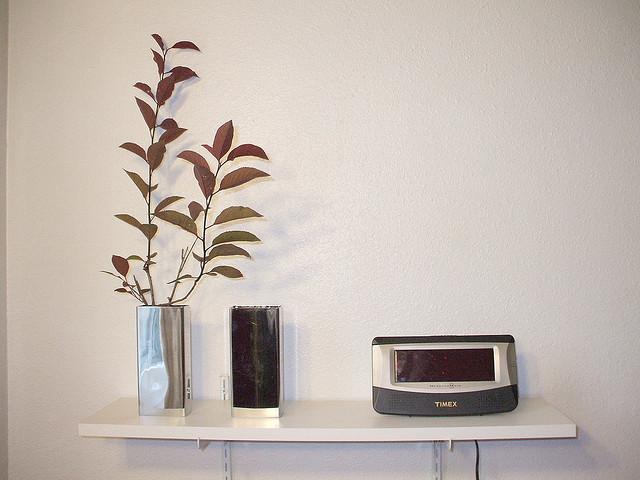Are the vases the same color?
Short answer required. No. What is next to the bear on the left?
Give a very brief answer. No bear. How much water does the plant need in the photo?
Keep it brief. Little. Is this wall red?
Write a very short answer. No. Is the plant alive/healthy?
Quick response, please. Yes. Is there a clock?
Write a very short answer. Yes. How many different flowers are there?
Concise answer only. 1. What room is this?
Concise answer only. Living room. What is in the vase?
Short answer required. Plant. What kind of appliance is this?
Answer briefly. Clock. What color is the shelf?
Concise answer only. White. What color are the flowers?
Keep it brief. Brown. How many vases are up against the wall?
Concise answer only. 2. How many hearts are there?
Be succinct. 0. 